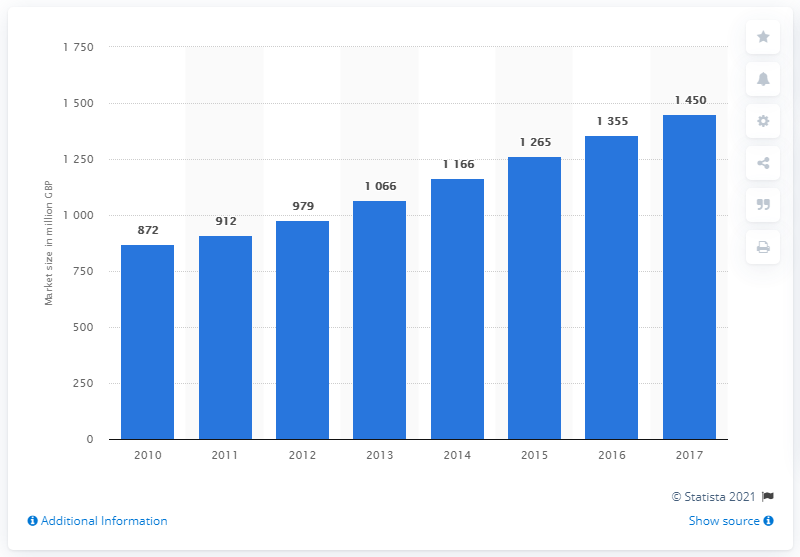List a handful of essential elements in this visual. In 2017, the project services and outsourcing segment was estimated to be approximately 1,450 in size. The project services and outsourcing segment began to grow in the UK in the year 2010. 